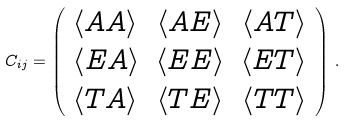<formula> <loc_0><loc_0><loc_500><loc_500>C _ { i j } = \left ( \begin{array} { l c r } \langle A A \rangle & \left < A E \right > & \left < A T \right > \\ \left < E A \right > & \left < E E \right > & \left < E T \right > \\ \left < T A \right > & \left < T E \right > & \left < T T \right > \\ \end{array} \right ) \, .</formula> 